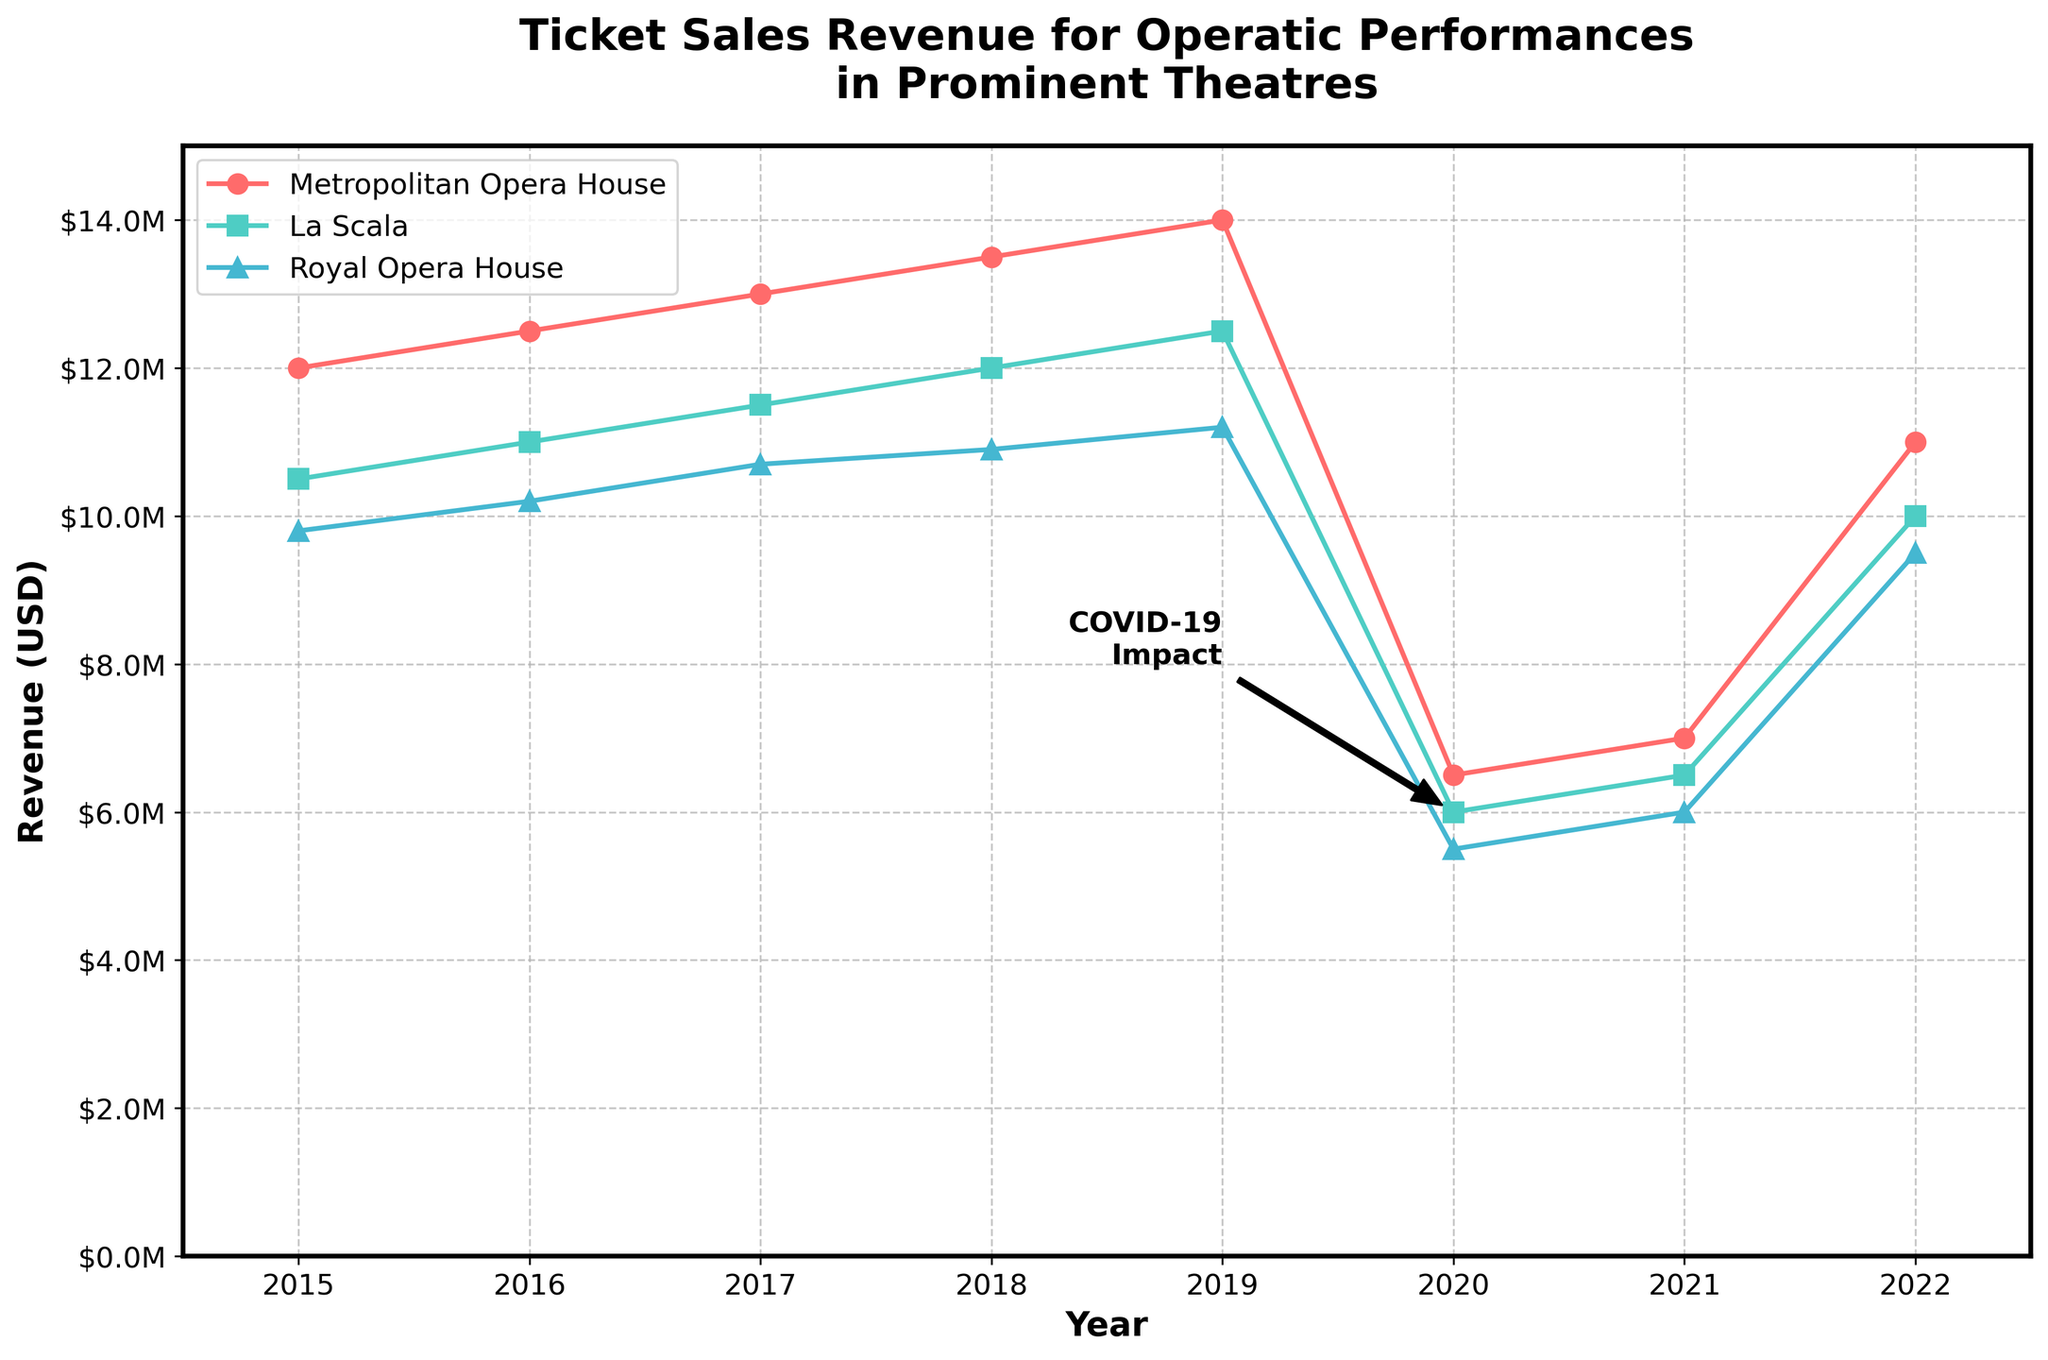When does the ticket sales revenue peak for the Metropolitan Opera House? The revenue for the Metropolitan Opera House peaks in 2019 at $14 million, as seen at the highest point of the orange line on the chart in 2019.
Answer: 2019 What significant event is annotated on the chart? The annotation "COVID-19 Impact" is visible on the chart, pointing to the sharp decline in revenues in 2020. This is marked with a black arrow pointing from 2019 to 2020.
Answer: COVID-19 Impact How much revenue did La Scala generate in 2022? By referring to the blue line representing La Scala, the revenue in 2022 is noted to be $10 million.
Answer: $10 million Which theatre had the lowest ticket sales revenue in 2020? The green line of the Royal Opera House reaches the lowest point in 2020 at $5.5 million compared to the other theatres.
Answer: Royal Opera House In which year did all three theatres experience a significant drop in revenue, and why? All three theatres experienced a significant drop in 2020. The annotation "COVID-19 Impact" explains the drop.
Answer: 2020 What is the overall trend in ticket sales revenue for the Royal Opera House from 2015 to 2022? The revenue for the Royal Opera House shows a gradual increase from 2015 to 2019, a sharp decline in 2020, and then a partial recovery up to 2022.
Answer: Increasing until 2019, then drop and partial recovery How much more revenue did the Metropolitan Opera House make in 2019 compared to 2016? The Metropolitan Opera House made $14 million in 2019 and $12.5 million in 2016. The difference is $14 million - $12.5 million = $1.5 million.
Answer: $1.5 million Between which consecutive years does the Royal Opera House show the most significant increase in ticket sales revenue? The Royal Opera House shows the most significant increase between 2015 and 2016, increasing from $9.8 million to $10.2 million, a difference of $0.4 million.
Answer: 2015-2016 What pattern do you observe in the ticket sales revenue for La Scala from 2015 to 2019? The revenue for La Scala steadily increases each year from $10.5 million in 2015 to $12.5 million in 2019.
Answer: Steady increase How often did the revenues of all three theatres surpass $10 million between 2015 and 2019? Between 2015 and 2019, the revenues of all three theatres surpassed $10 million every year within this period, except for the Royal Opera House in 2015 which had $9.8 million.
Answer: Most years except Royal Opera House in 2015 